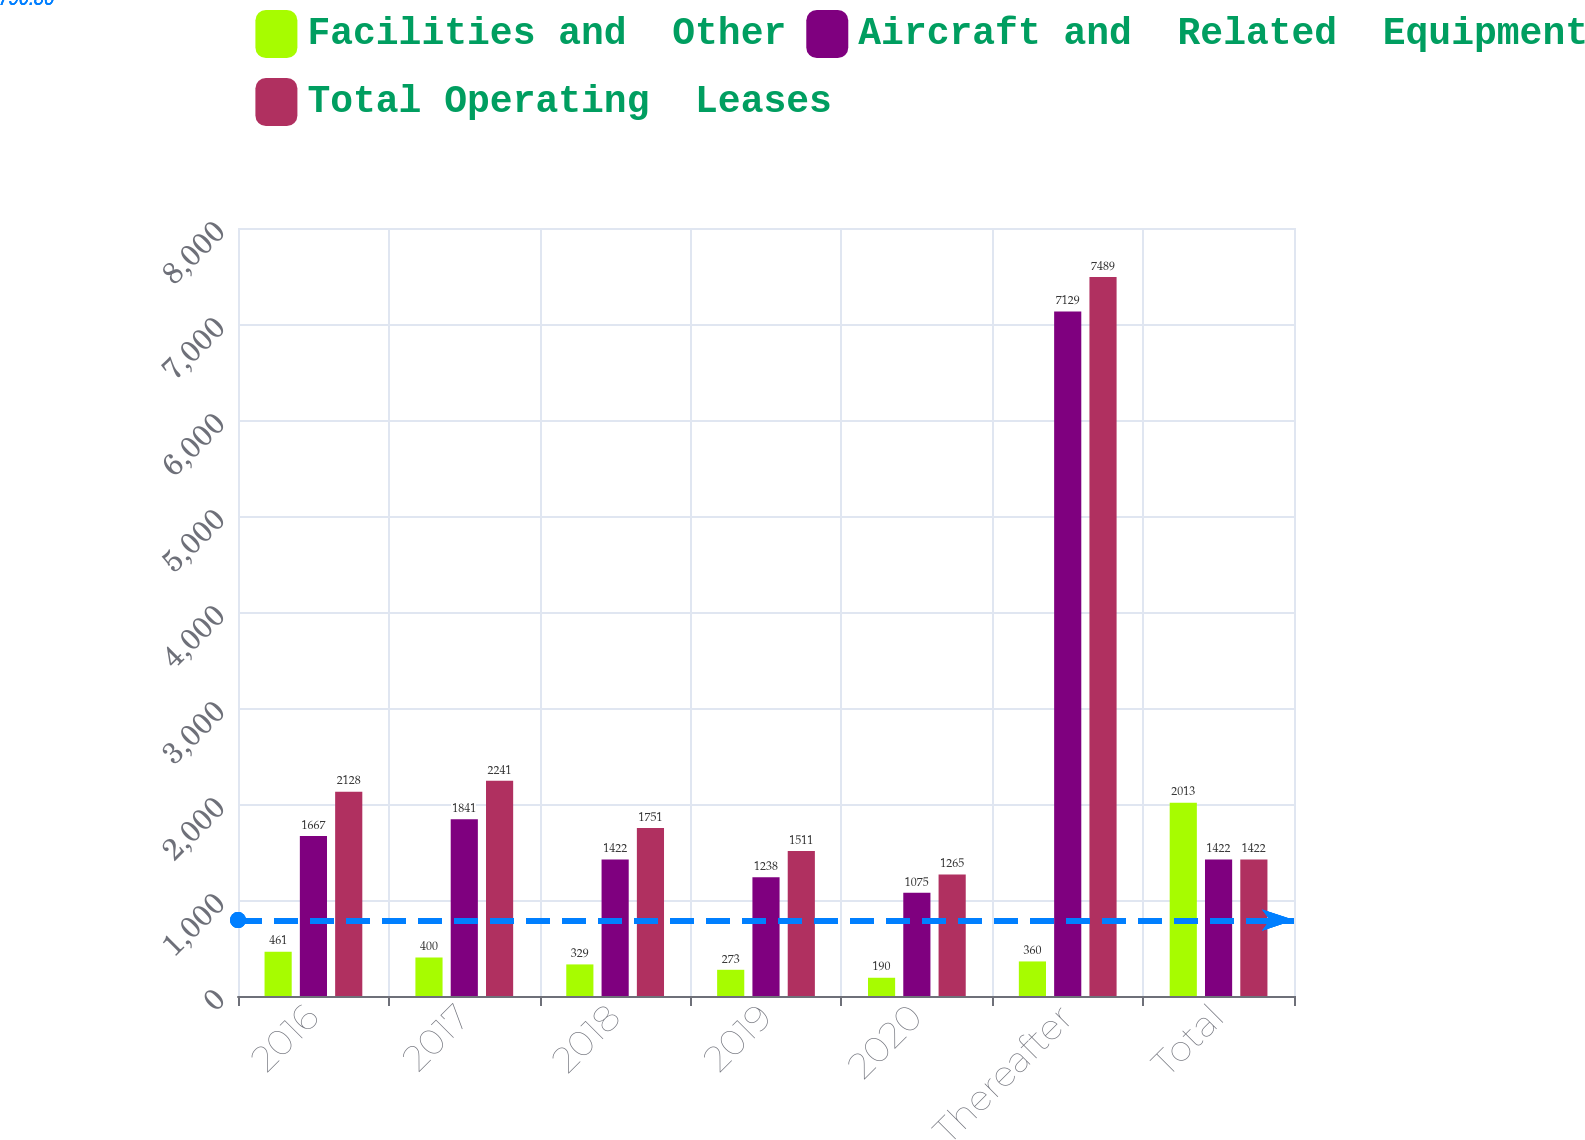Convert chart to OTSL. <chart><loc_0><loc_0><loc_500><loc_500><stacked_bar_chart><ecel><fcel>2016<fcel>2017<fcel>2018<fcel>2019<fcel>2020<fcel>Thereafter<fcel>Total<nl><fcel>Facilities and  Other<fcel>461<fcel>400<fcel>329<fcel>273<fcel>190<fcel>360<fcel>2013<nl><fcel>Aircraft and  Related  Equipment<fcel>1667<fcel>1841<fcel>1422<fcel>1238<fcel>1075<fcel>7129<fcel>1422<nl><fcel>Total Operating  Leases<fcel>2128<fcel>2241<fcel>1751<fcel>1511<fcel>1265<fcel>7489<fcel>1422<nl></chart> 